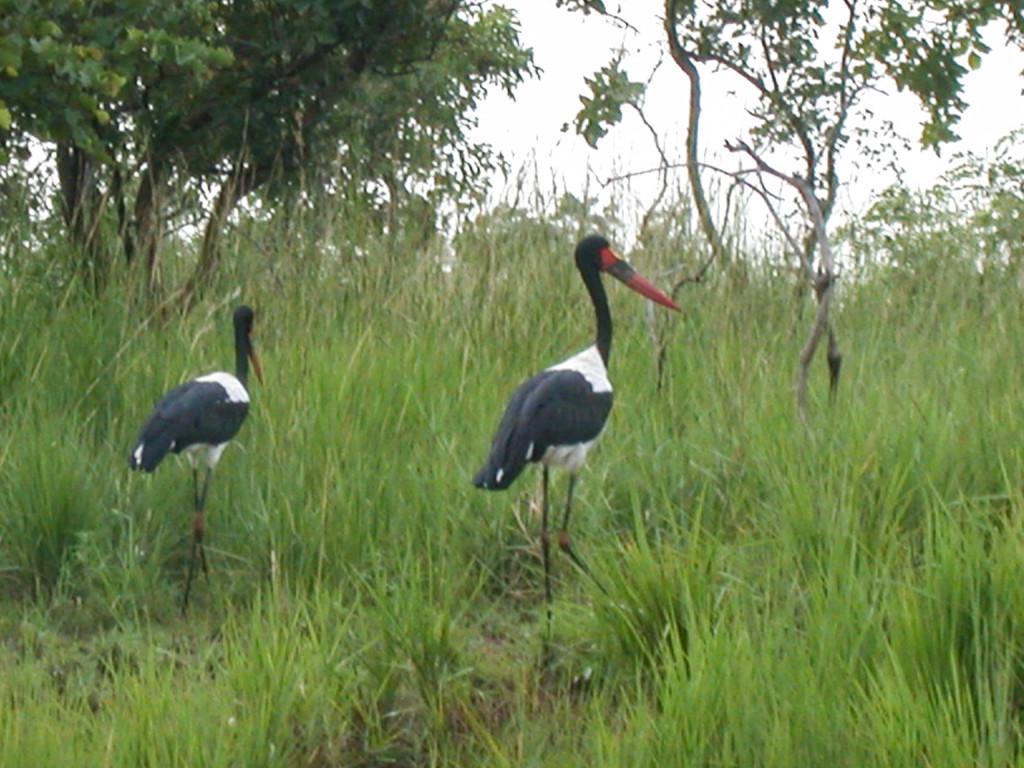How would you summarize this image in a sentence or two? This image consists of two cranes walking on the ground. They are in black color. At the bottom, we can see the green grass. In the background, there are trees. They are in black color. At the top, there is sky. 